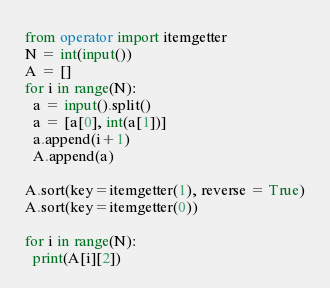<code> <loc_0><loc_0><loc_500><loc_500><_Python_>from operator import itemgetter
N = int(input())
A = []
for i in range(N):
  a = input().split()
  a = [a[0], int(a[1])]
  a.append(i+1)
  A.append(a)

A.sort(key=itemgetter(1), reverse = True)
A.sort(key=itemgetter(0))

for i in range(N):
  print(A[i][2])


</code> 